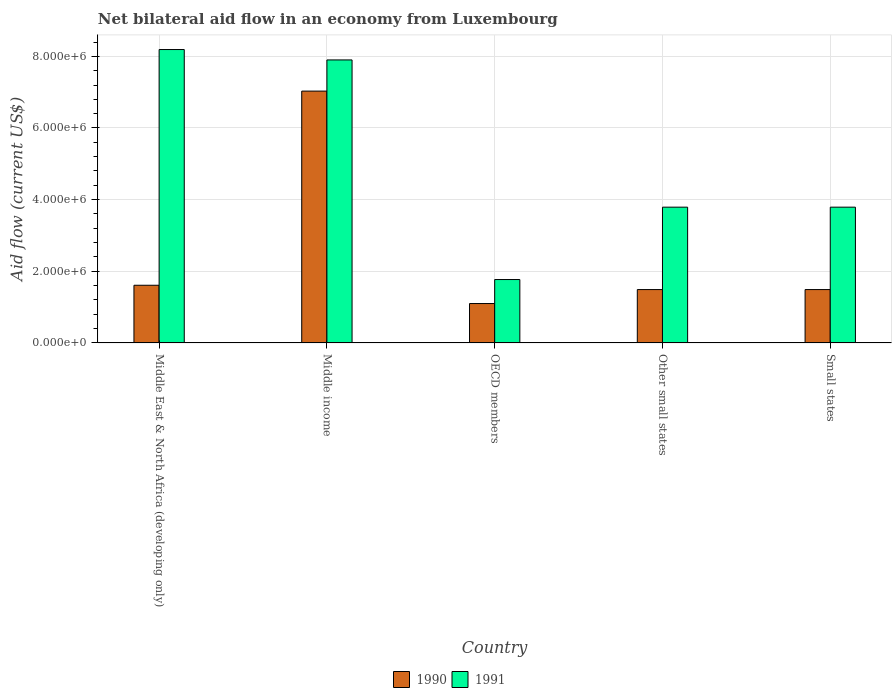How many different coloured bars are there?
Ensure brevity in your answer.  2. How many groups of bars are there?
Your answer should be very brief. 5. Are the number of bars per tick equal to the number of legend labels?
Offer a terse response. Yes. Are the number of bars on each tick of the X-axis equal?
Provide a short and direct response. Yes. What is the label of the 3rd group of bars from the left?
Provide a short and direct response. OECD members. What is the net bilateral aid flow in 1991 in Middle East & North Africa (developing only)?
Your answer should be very brief. 8.19e+06. Across all countries, what is the maximum net bilateral aid flow in 1990?
Offer a very short reply. 7.03e+06. Across all countries, what is the minimum net bilateral aid flow in 1991?
Give a very brief answer. 1.77e+06. In which country was the net bilateral aid flow in 1990 maximum?
Ensure brevity in your answer.  Middle income. In which country was the net bilateral aid flow in 1991 minimum?
Your response must be concise. OECD members. What is the total net bilateral aid flow in 1990 in the graph?
Give a very brief answer. 1.27e+07. What is the difference between the net bilateral aid flow in 1990 in OECD members and that in Other small states?
Offer a very short reply. -3.90e+05. What is the average net bilateral aid flow in 1990 per country?
Your answer should be compact. 2.54e+06. What is the difference between the net bilateral aid flow of/in 1990 and net bilateral aid flow of/in 1991 in Middle East & North Africa (developing only)?
Give a very brief answer. -6.58e+06. In how many countries, is the net bilateral aid flow in 1991 greater than 3200000 US$?
Provide a succinct answer. 4. What is the ratio of the net bilateral aid flow in 1990 in Middle East & North Africa (developing only) to that in Other small states?
Give a very brief answer. 1.08. Is the difference between the net bilateral aid flow in 1990 in Middle East & North Africa (developing only) and Other small states greater than the difference between the net bilateral aid flow in 1991 in Middle East & North Africa (developing only) and Other small states?
Your answer should be very brief. No. What is the difference between the highest and the second highest net bilateral aid flow in 1991?
Keep it short and to the point. 2.90e+05. What is the difference between the highest and the lowest net bilateral aid flow in 1990?
Offer a terse response. 5.93e+06. What does the 1st bar from the left in Small states represents?
Give a very brief answer. 1990. What does the 1st bar from the right in Middle income represents?
Keep it short and to the point. 1991. Are all the bars in the graph horizontal?
Offer a very short reply. No. How many countries are there in the graph?
Your answer should be very brief. 5. What is the difference between two consecutive major ticks on the Y-axis?
Your answer should be very brief. 2.00e+06. Are the values on the major ticks of Y-axis written in scientific E-notation?
Your answer should be very brief. Yes. Does the graph contain any zero values?
Make the answer very short. No. Does the graph contain grids?
Offer a very short reply. Yes. What is the title of the graph?
Provide a short and direct response. Net bilateral aid flow in an economy from Luxembourg. Does "2012" appear as one of the legend labels in the graph?
Your answer should be very brief. No. What is the Aid flow (current US$) in 1990 in Middle East & North Africa (developing only)?
Your answer should be compact. 1.61e+06. What is the Aid flow (current US$) in 1991 in Middle East & North Africa (developing only)?
Provide a succinct answer. 8.19e+06. What is the Aid flow (current US$) of 1990 in Middle income?
Your response must be concise. 7.03e+06. What is the Aid flow (current US$) of 1991 in Middle income?
Your response must be concise. 7.90e+06. What is the Aid flow (current US$) in 1990 in OECD members?
Make the answer very short. 1.10e+06. What is the Aid flow (current US$) in 1991 in OECD members?
Your response must be concise. 1.77e+06. What is the Aid flow (current US$) of 1990 in Other small states?
Offer a terse response. 1.49e+06. What is the Aid flow (current US$) of 1991 in Other small states?
Offer a very short reply. 3.79e+06. What is the Aid flow (current US$) in 1990 in Small states?
Offer a very short reply. 1.49e+06. What is the Aid flow (current US$) of 1991 in Small states?
Ensure brevity in your answer.  3.79e+06. Across all countries, what is the maximum Aid flow (current US$) in 1990?
Provide a succinct answer. 7.03e+06. Across all countries, what is the maximum Aid flow (current US$) in 1991?
Offer a terse response. 8.19e+06. Across all countries, what is the minimum Aid flow (current US$) of 1990?
Your answer should be very brief. 1.10e+06. Across all countries, what is the minimum Aid flow (current US$) in 1991?
Provide a short and direct response. 1.77e+06. What is the total Aid flow (current US$) of 1990 in the graph?
Your answer should be compact. 1.27e+07. What is the total Aid flow (current US$) of 1991 in the graph?
Give a very brief answer. 2.54e+07. What is the difference between the Aid flow (current US$) in 1990 in Middle East & North Africa (developing only) and that in Middle income?
Provide a succinct answer. -5.42e+06. What is the difference between the Aid flow (current US$) of 1990 in Middle East & North Africa (developing only) and that in OECD members?
Keep it short and to the point. 5.10e+05. What is the difference between the Aid flow (current US$) in 1991 in Middle East & North Africa (developing only) and that in OECD members?
Make the answer very short. 6.42e+06. What is the difference between the Aid flow (current US$) of 1991 in Middle East & North Africa (developing only) and that in Other small states?
Ensure brevity in your answer.  4.40e+06. What is the difference between the Aid flow (current US$) in 1990 in Middle East & North Africa (developing only) and that in Small states?
Ensure brevity in your answer.  1.20e+05. What is the difference between the Aid flow (current US$) of 1991 in Middle East & North Africa (developing only) and that in Small states?
Offer a terse response. 4.40e+06. What is the difference between the Aid flow (current US$) in 1990 in Middle income and that in OECD members?
Make the answer very short. 5.93e+06. What is the difference between the Aid flow (current US$) in 1991 in Middle income and that in OECD members?
Provide a succinct answer. 6.13e+06. What is the difference between the Aid flow (current US$) of 1990 in Middle income and that in Other small states?
Ensure brevity in your answer.  5.54e+06. What is the difference between the Aid flow (current US$) of 1991 in Middle income and that in Other small states?
Provide a succinct answer. 4.11e+06. What is the difference between the Aid flow (current US$) of 1990 in Middle income and that in Small states?
Your response must be concise. 5.54e+06. What is the difference between the Aid flow (current US$) in 1991 in Middle income and that in Small states?
Offer a terse response. 4.11e+06. What is the difference between the Aid flow (current US$) in 1990 in OECD members and that in Other small states?
Make the answer very short. -3.90e+05. What is the difference between the Aid flow (current US$) of 1991 in OECD members and that in Other small states?
Keep it short and to the point. -2.02e+06. What is the difference between the Aid flow (current US$) in 1990 in OECD members and that in Small states?
Your response must be concise. -3.90e+05. What is the difference between the Aid flow (current US$) in 1991 in OECD members and that in Small states?
Offer a terse response. -2.02e+06. What is the difference between the Aid flow (current US$) of 1990 in Middle East & North Africa (developing only) and the Aid flow (current US$) of 1991 in Middle income?
Provide a short and direct response. -6.29e+06. What is the difference between the Aid flow (current US$) in 1990 in Middle East & North Africa (developing only) and the Aid flow (current US$) in 1991 in Other small states?
Offer a terse response. -2.18e+06. What is the difference between the Aid flow (current US$) in 1990 in Middle East & North Africa (developing only) and the Aid flow (current US$) in 1991 in Small states?
Offer a very short reply. -2.18e+06. What is the difference between the Aid flow (current US$) in 1990 in Middle income and the Aid flow (current US$) in 1991 in OECD members?
Provide a short and direct response. 5.26e+06. What is the difference between the Aid flow (current US$) of 1990 in Middle income and the Aid flow (current US$) of 1991 in Other small states?
Your response must be concise. 3.24e+06. What is the difference between the Aid flow (current US$) of 1990 in Middle income and the Aid flow (current US$) of 1991 in Small states?
Your answer should be compact. 3.24e+06. What is the difference between the Aid flow (current US$) in 1990 in OECD members and the Aid flow (current US$) in 1991 in Other small states?
Offer a very short reply. -2.69e+06. What is the difference between the Aid flow (current US$) in 1990 in OECD members and the Aid flow (current US$) in 1991 in Small states?
Make the answer very short. -2.69e+06. What is the difference between the Aid flow (current US$) of 1990 in Other small states and the Aid flow (current US$) of 1991 in Small states?
Make the answer very short. -2.30e+06. What is the average Aid flow (current US$) of 1990 per country?
Make the answer very short. 2.54e+06. What is the average Aid flow (current US$) of 1991 per country?
Give a very brief answer. 5.09e+06. What is the difference between the Aid flow (current US$) of 1990 and Aid flow (current US$) of 1991 in Middle East & North Africa (developing only)?
Provide a short and direct response. -6.58e+06. What is the difference between the Aid flow (current US$) of 1990 and Aid flow (current US$) of 1991 in Middle income?
Your answer should be compact. -8.70e+05. What is the difference between the Aid flow (current US$) in 1990 and Aid flow (current US$) in 1991 in OECD members?
Your answer should be very brief. -6.70e+05. What is the difference between the Aid flow (current US$) in 1990 and Aid flow (current US$) in 1991 in Other small states?
Your response must be concise. -2.30e+06. What is the difference between the Aid flow (current US$) of 1990 and Aid flow (current US$) of 1991 in Small states?
Make the answer very short. -2.30e+06. What is the ratio of the Aid flow (current US$) of 1990 in Middle East & North Africa (developing only) to that in Middle income?
Give a very brief answer. 0.23. What is the ratio of the Aid flow (current US$) in 1991 in Middle East & North Africa (developing only) to that in Middle income?
Your answer should be very brief. 1.04. What is the ratio of the Aid flow (current US$) of 1990 in Middle East & North Africa (developing only) to that in OECD members?
Your response must be concise. 1.46. What is the ratio of the Aid flow (current US$) in 1991 in Middle East & North Africa (developing only) to that in OECD members?
Provide a succinct answer. 4.63. What is the ratio of the Aid flow (current US$) of 1990 in Middle East & North Africa (developing only) to that in Other small states?
Provide a short and direct response. 1.08. What is the ratio of the Aid flow (current US$) in 1991 in Middle East & North Africa (developing only) to that in Other small states?
Keep it short and to the point. 2.16. What is the ratio of the Aid flow (current US$) in 1990 in Middle East & North Africa (developing only) to that in Small states?
Provide a short and direct response. 1.08. What is the ratio of the Aid flow (current US$) of 1991 in Middle East & North Africa (developing only) to that in Small states?
Your response must be concise. 2.16. What is the ratio of the Aid flow (current US$) in 1990 in Middle income to that in OECD members?
Provide a succinct answer. 6.39. What is the ratio of the Aid flow (current US$) of 1991 in Middle income to that in OECD members?
Your answer should be compact. 4.46. What is the ratio of the Aid flow (current US$) in 1990 in Middle income to that in Other small states?
Give a very brief answer. 4.72. What is the ratio of the Aid flow (current US$) of 1991 in Middle income to that in Other small states?
Give a very brief answer. 2.08. What is the ratio of the Aid flow (current US$) of 1990 in Middle income to that in Small states?
Keep it short and to the point. 4.72. What is the ratio of the Aid flow (current US$) of 1991 in Middle income to that in Small states?
Give a very brief answer. 2.08. What is the ratio of the Aid flow (current US$) of 1990 in OECD members to that in Other small states?
Give a very brief answer. 0.74. What is the ratio of the Aid flow (current US$) in 1991 in OECD members to that in Other small states?
Give a very brief answer. 0.47. What is the ratio of the Aid flow (current US$) in 1990 in OECD members to that in Small states?
Your answer should be compact. 0.74. What is the ratio of the Aid flow (current US$) in 1991 in OECD members to that in Small states?
Your answer should be very brief. 0.47. What is the difference between the highest and the second highest Aid flow (current US$) in 1990?
Make the answer very short. 5.42e+06. What is the difference between the highest and the lowest Aid flow (current US$) of 1990?
Give a very brief answer. 5.93e+06. What is the difference between the highest and the lowest Aid flow (current US$) in 1991?
Make the answer very short. 6.42e+06. 